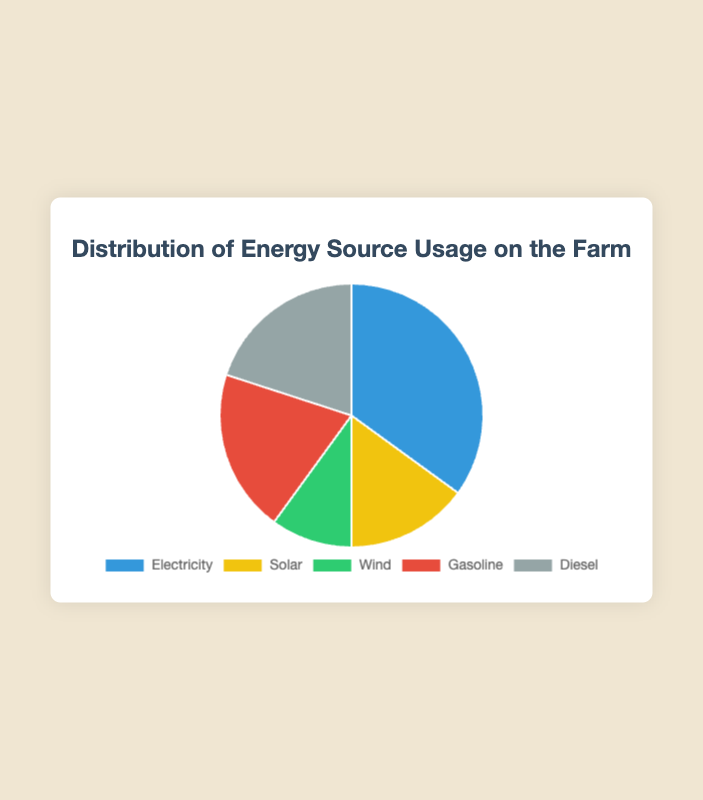Which energy source has the highest percentage of usage on the farm? From the pie chart, the energy source with the highest percentage can be identified by finding the largest segment. The Electricity segment occupies 35%.
Answer: Electricity What is the combined percentage of Gasoline and Diesel usage on the farm? Add the percentages of Gasoline and Diesel from the pie chart. Gasoline usage is 20% and Diesel usage is also 20%. So, 20% + 20% = 40%.
Answer: 40% Which two energy sources have identical percentages? Look for segments in the pie chart that are equal in size. Gasoline and Diesel both show 20% usage.
Answer: Gasoline and Diesel What percentage of energy usage comes from renewable sources (Solar and Wind)? Add the percentages of Solar and Wind from the pie chart. Solar is 15% and Wind is 10%. So, 15% + 10% = 25%.
Answer: 25% By how much does the percentage of Electricity usage exceed that of Wind? Subtract the percentage of Wind from Electricity. Electricity usage is 35% and Wind usage is 10%. So, 35% - 10% = 25%.
Answer: 25% What is the color representation for the Solar energy source? Identify the segment labeled 'Solar' in the pie chart and note its color. The Solar segment is represented by a yellow color.
Answer: Yellow How does the percentage of Electricity usage compare to the sum of Gasoline and Diesel usage? The percentage of Electricity usage is 35%. The sum of Gasoline and Diesel usage is 20% + 20% = 40%. Electricity usage (35%) is less than the sum of Gasoline and Diesel (40%).
Answer: Less than If the farm increases its Solar usage by 5%, what would be the new percentage of Solar usage? Add 5% to the current Solar usage percentage. Current Solar usage is 15%, so 15% + 5% = 20%.
Answer: 20% List the energy sources in descending order based on their usage percentages. Order the energy sources based on their percentages from highest to lowest. Electricity (35%), Gasoline (20%), Diesel (20%), Solar (15%), Wind (10%).
Answer: Electricity, Gasoline, Diesel, Solar, Wind 